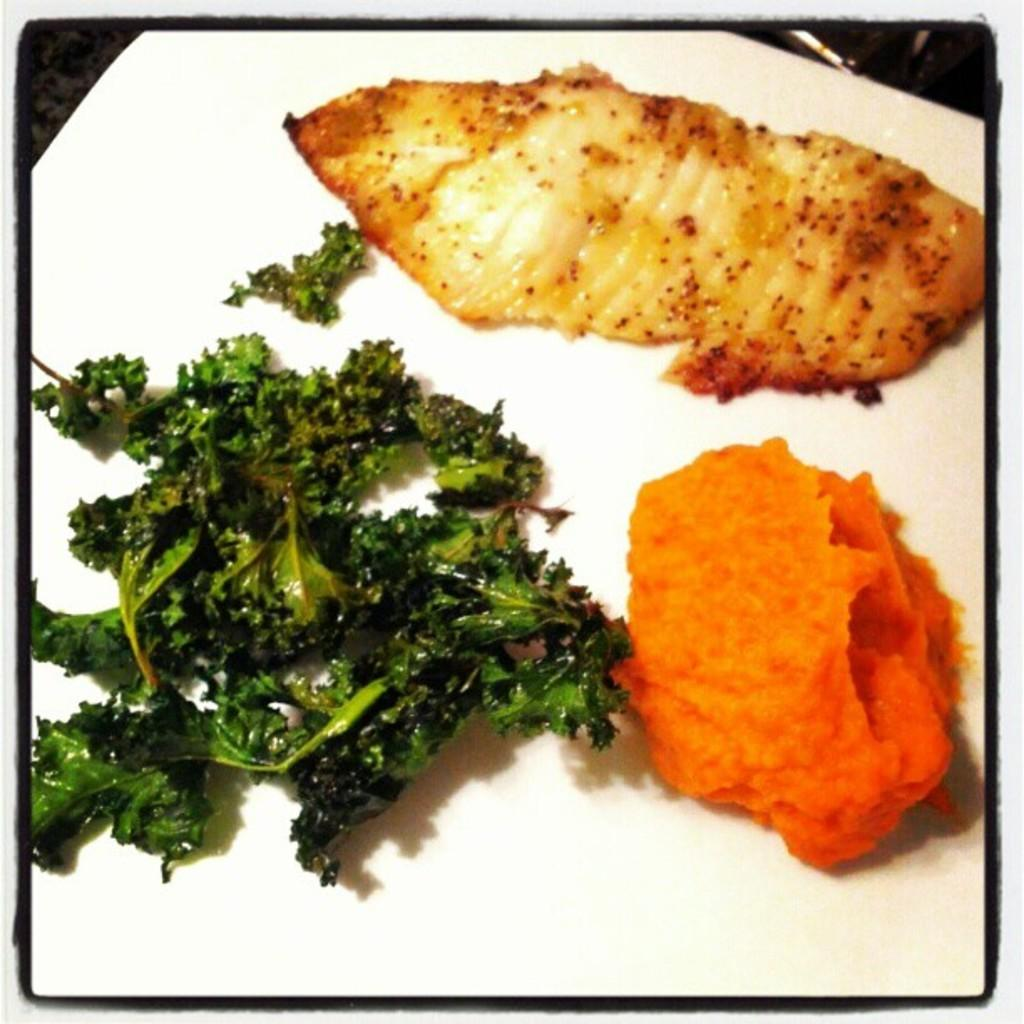What can be seen in the image? There are food items in the image. What is the color of the surface on which the food items are placed? The food items are on a white surface. What type of story is being told by the grape in the image? There is no grape present in the image, so no story can be told by a grape. 